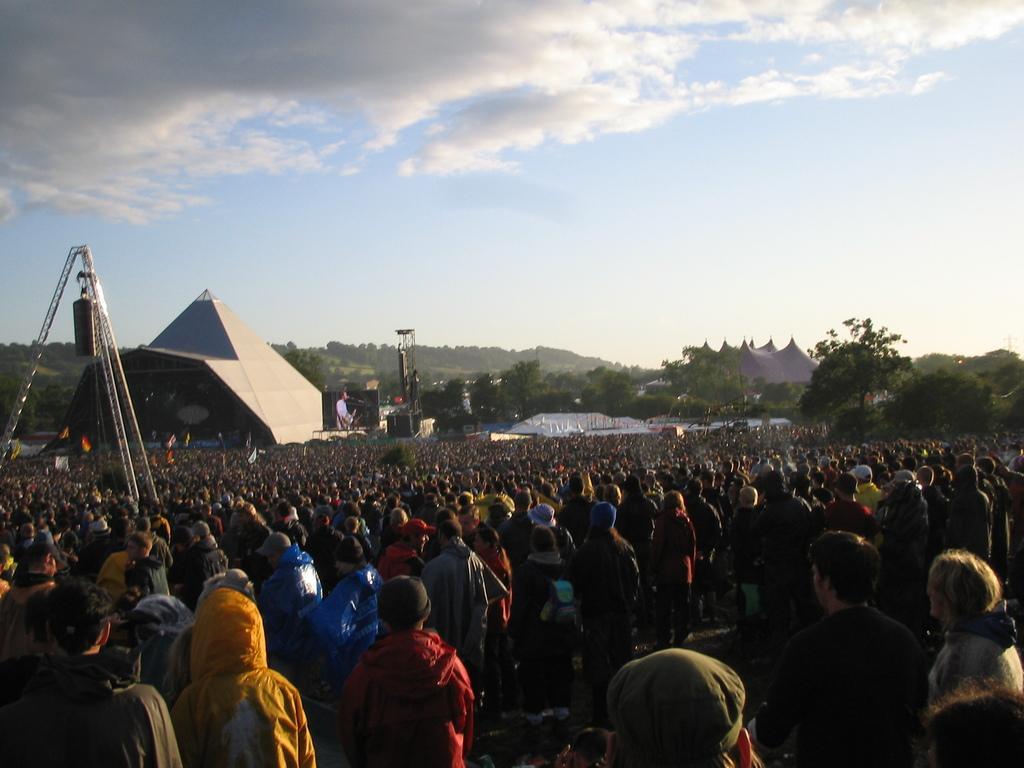What is happening in the foreground of the image? There are many people standing in the foreground of the image. What type of natural elements can be seen in the image? Trees are visible in the image. What kind of platform or area is present in the image? It appears to be a stage in the image. What type of man-made structures are present in the image? There are building structures in the image. What is visible in the background of the image? The sky is visible in the background of the image. Where is the sign indicating the location of the nearest restroom in the image? There is no sign present in the image. What type of map is visible on the stage in the image? There is no map present in the image. 